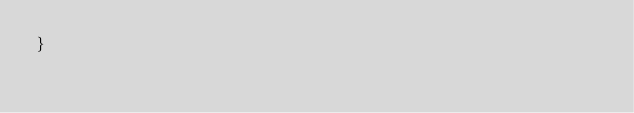<code> <loc_0><loc_0><loc_500><loc_500><_Java_>}
</code> 